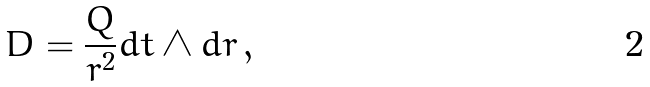<formula> <loc_0><loc_0><loc_500><loc_500>D = \frac { Q } { r ^ { 2 } } d t \wedge d r \, ,</formula> 